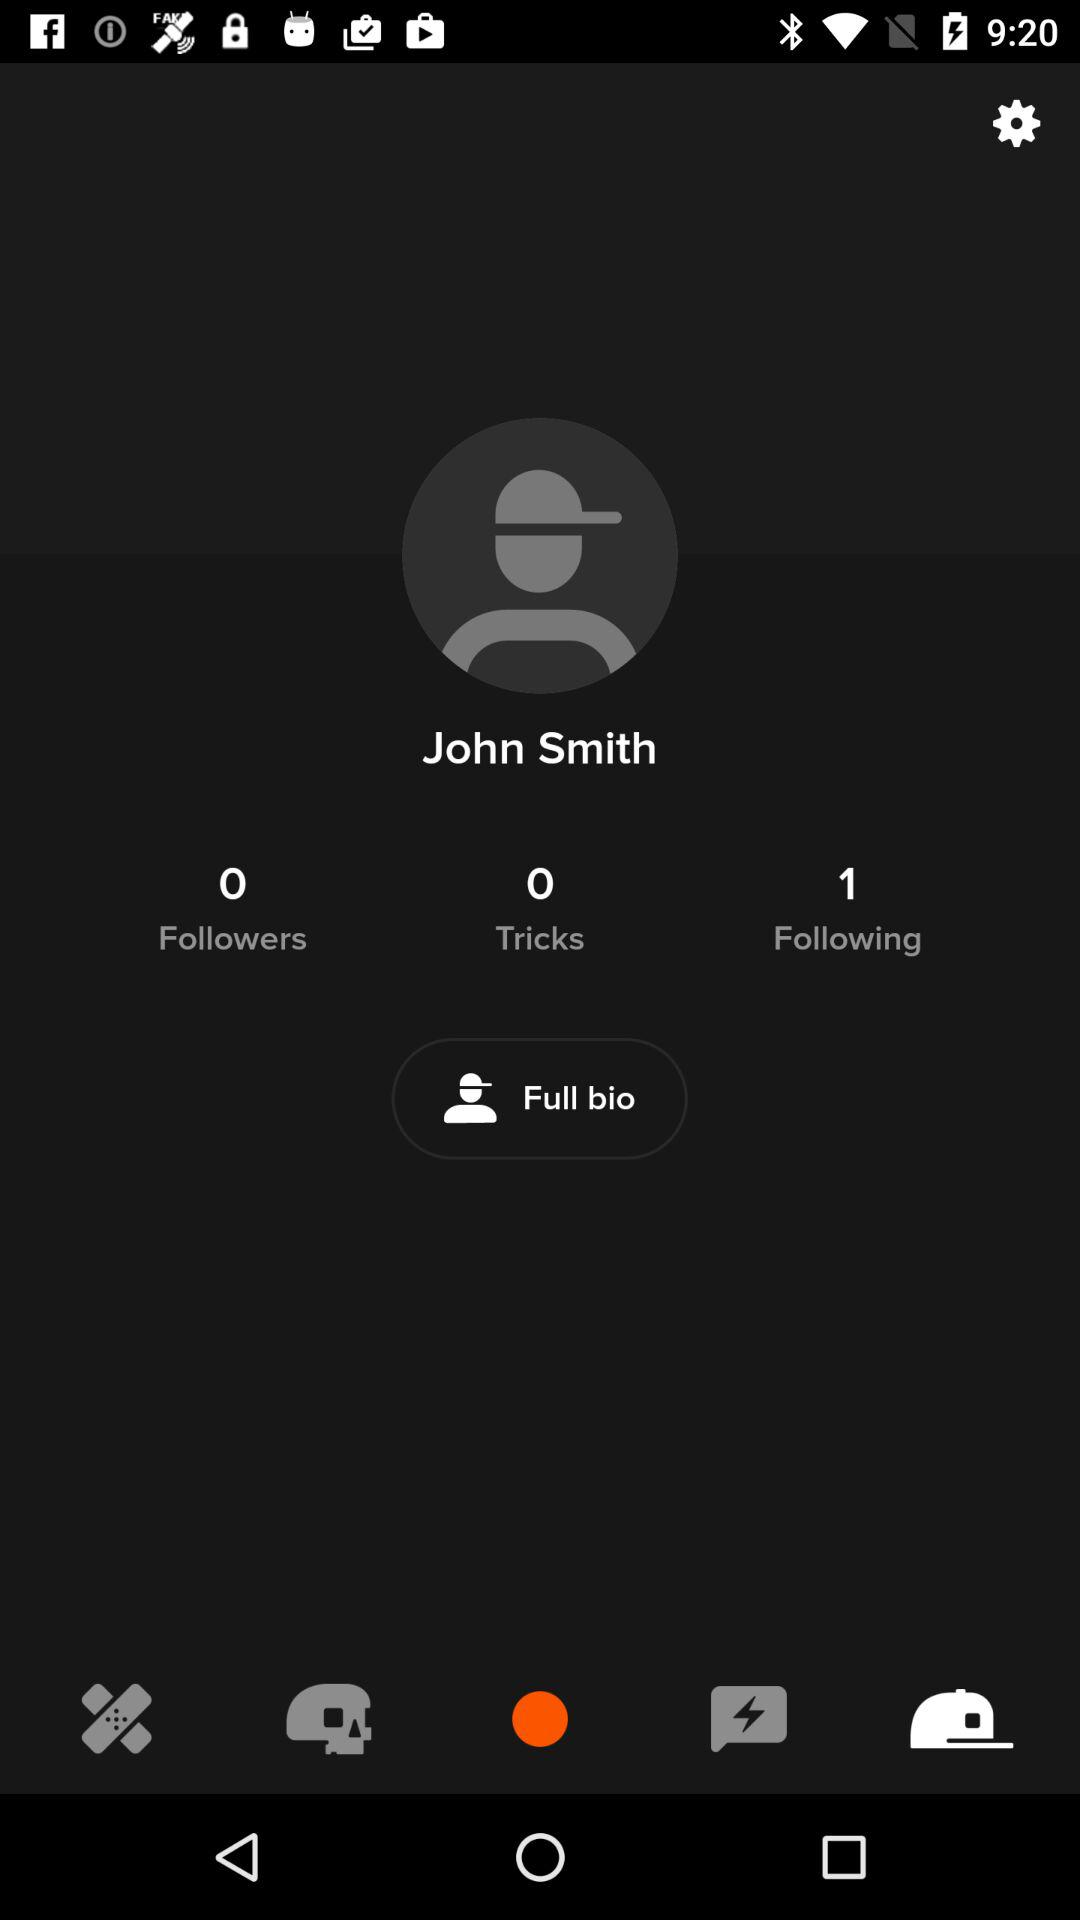How many people are following John Smith? There is one person who is following John Smith. 